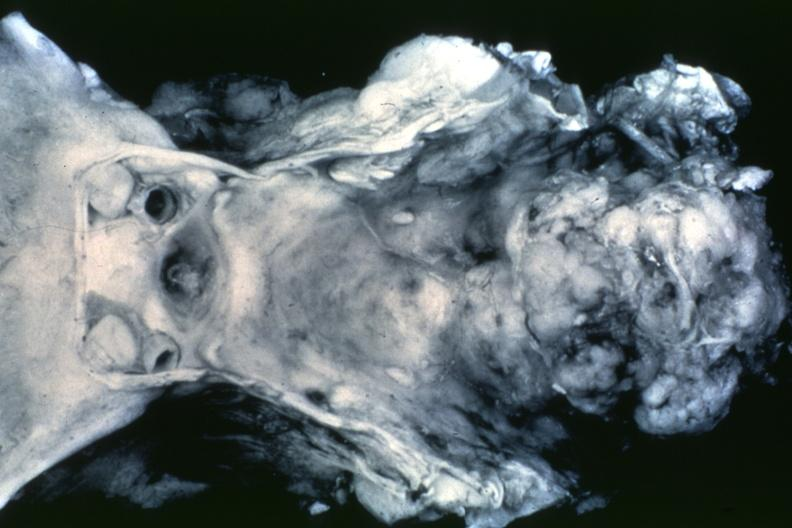does this image show black and white dr garcia tumors b68?
Answer the question using a single word or phrase. Yes 